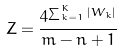<formula> <loc_0><loc_0><loc_500><loc_500>Z = \frac { 4 ^ { \sum _ { k = 1 } ^ { K } | W _ { k } | } } { m - n + 1 }</formula> 